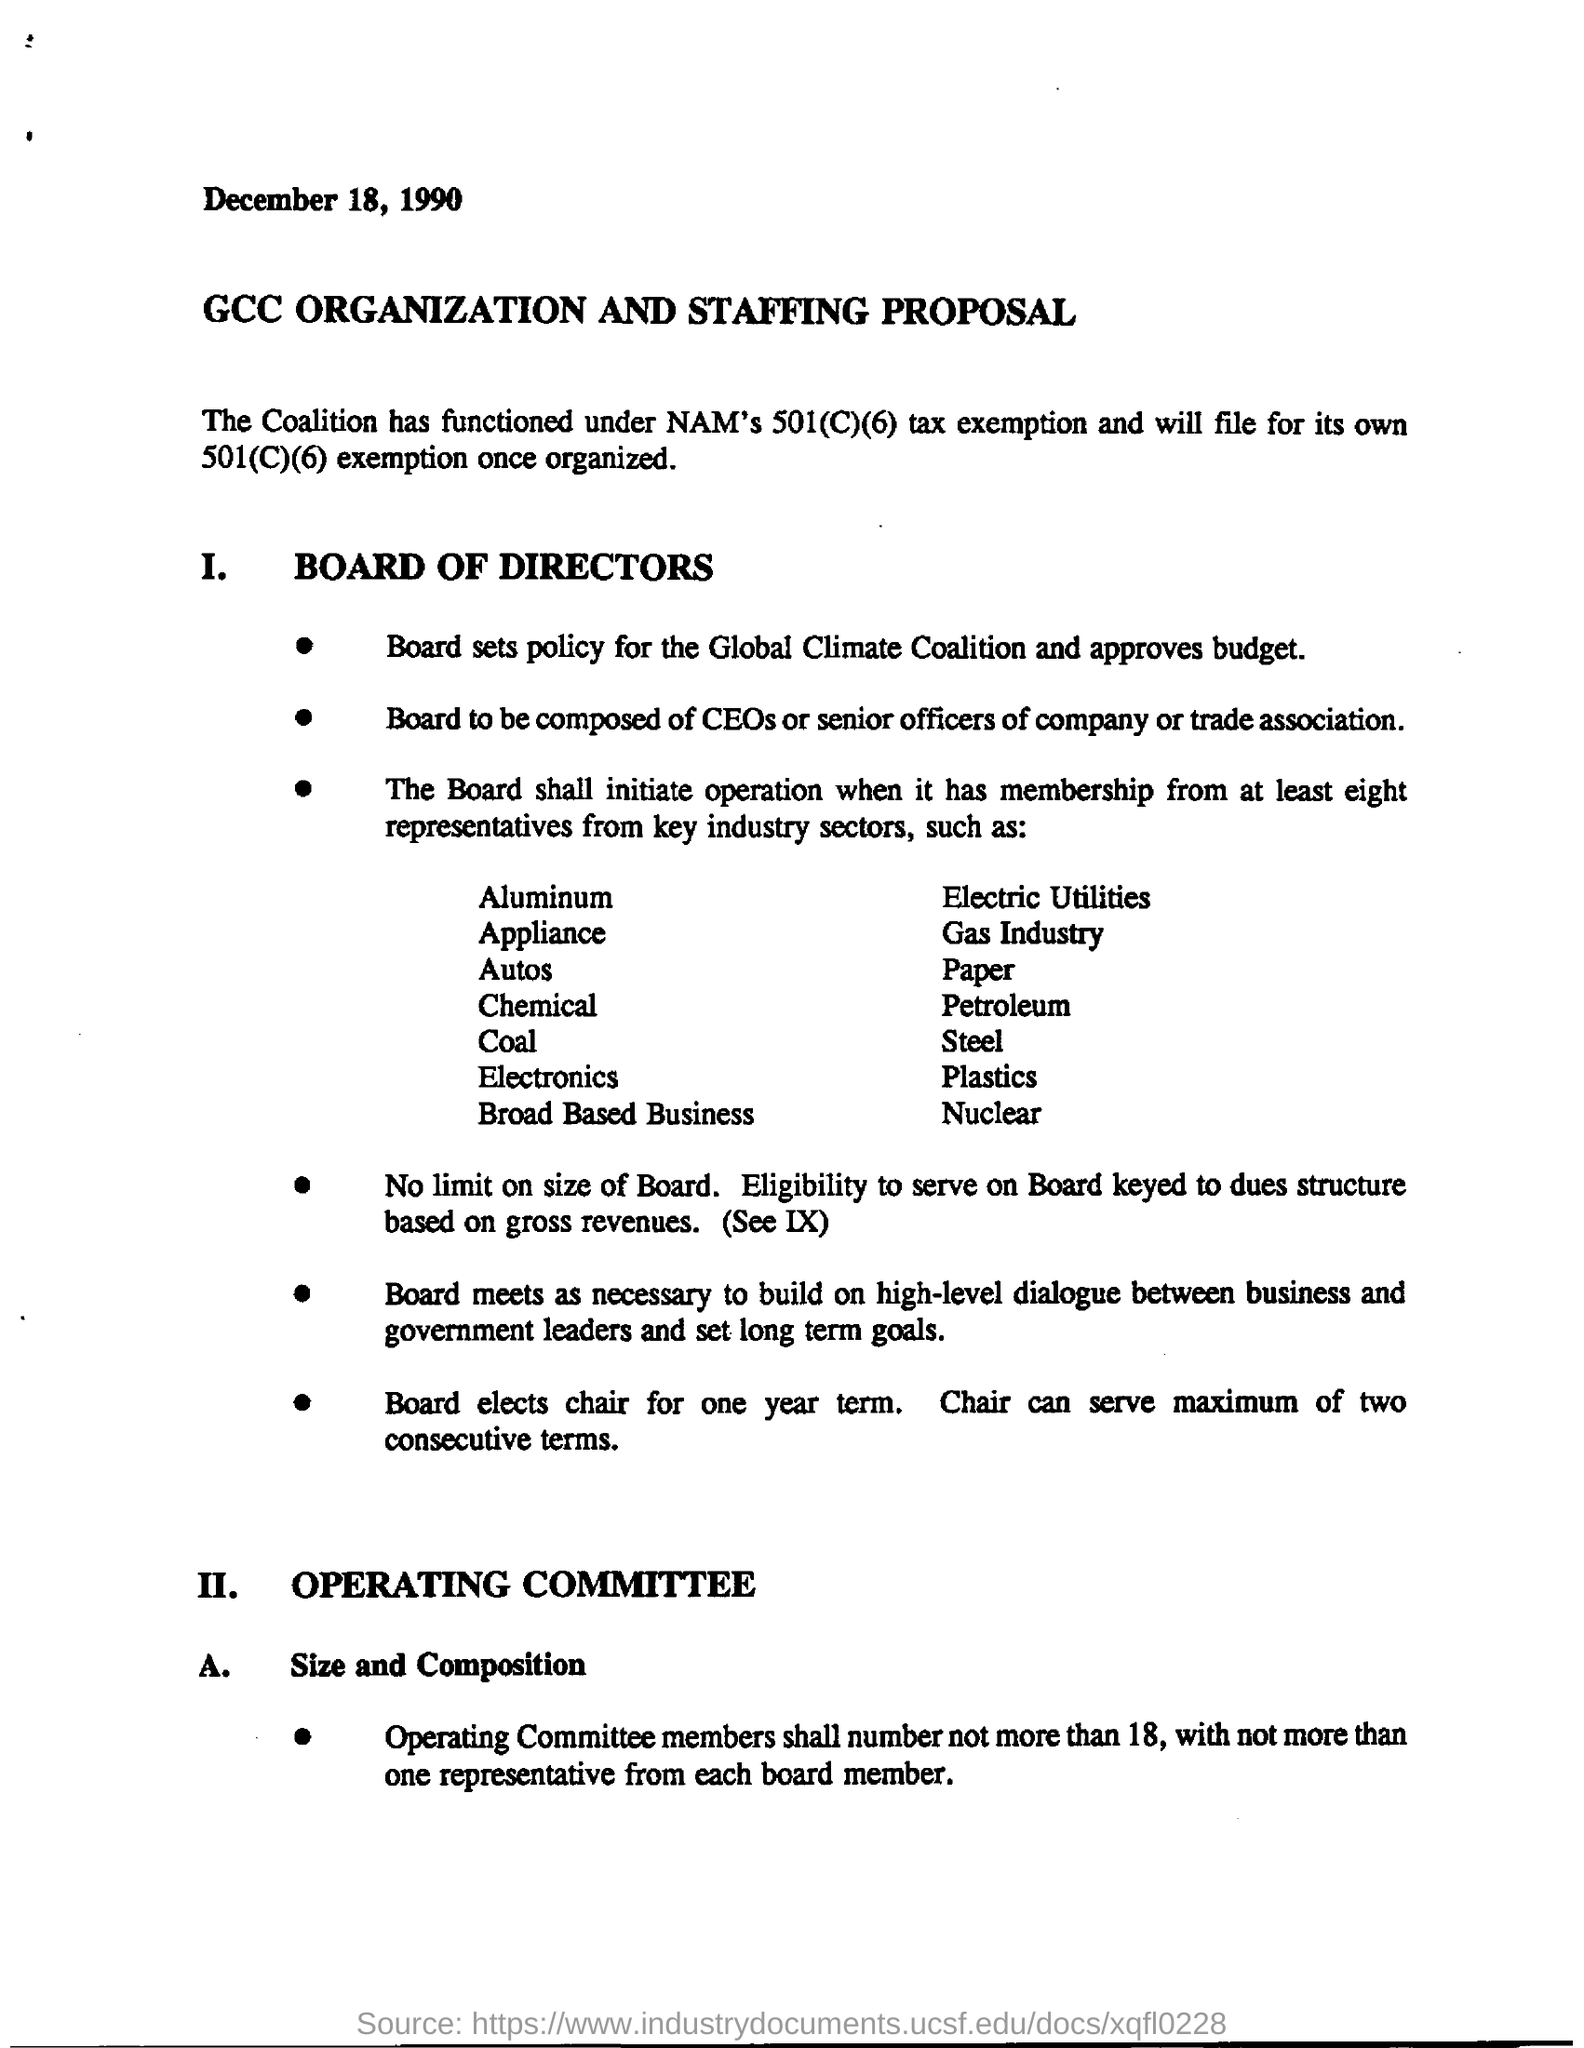What is the date mentioned in the document?
Your response must be concise. December 18, 1990. What is the title of the document?
Ensure brevity in your answer.  GCC Organization and Staffing Proposal. 